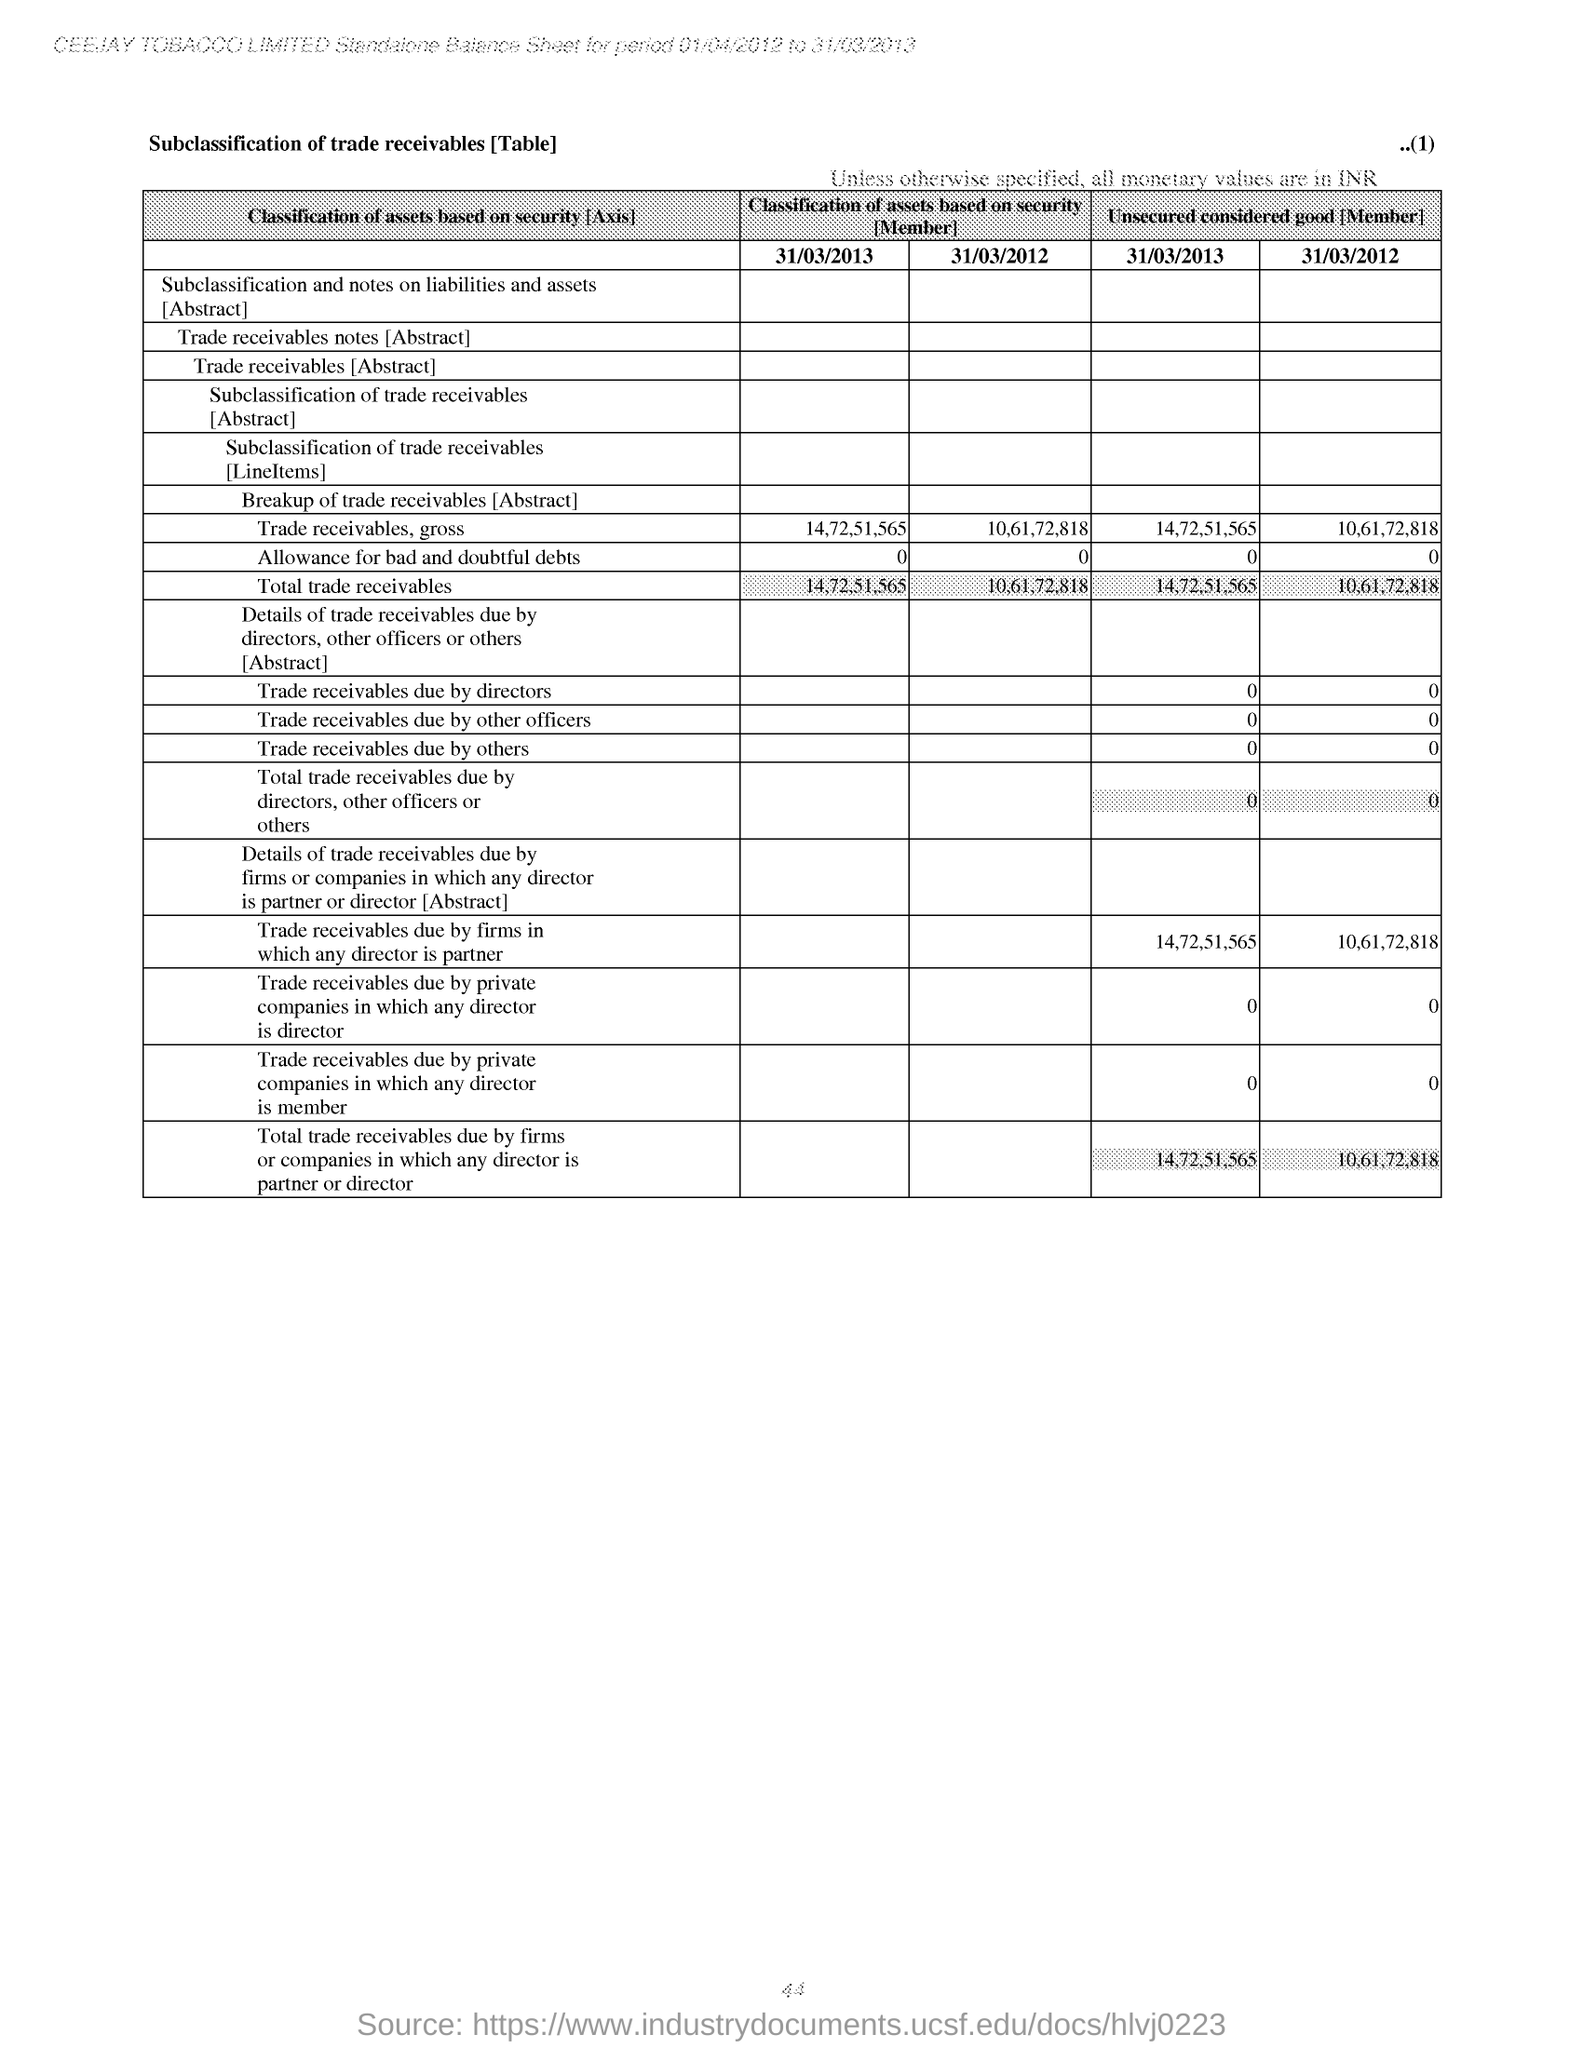Give some essential details in this illustration. On March 31, 2013, the total trade receivables of a particular class of assets were 14,72,51,565. These assets were classified based on their security. On March 31, 2013, the classification of the trade receivables, gross as an asset was based on its security, with a total value of 14,72,51,565. 